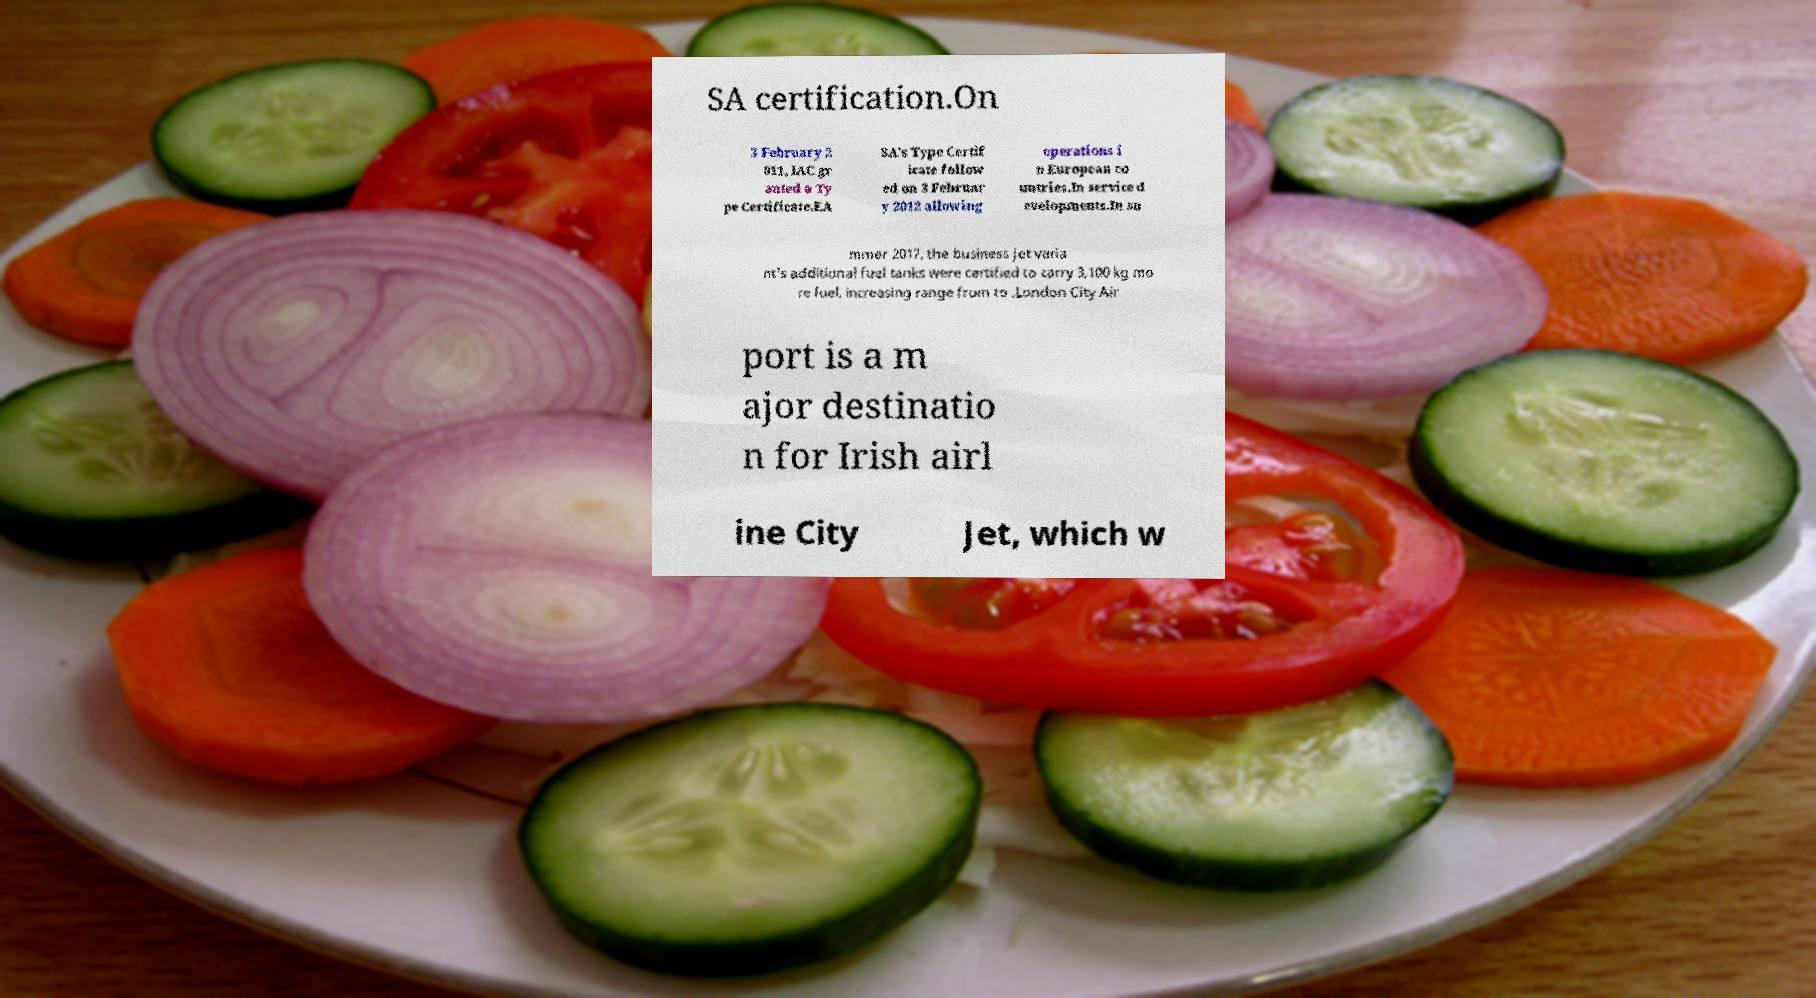Could you extract and type out the text from this image? SA certification.On 3 February 2 011, IAC gr anted a Ty pe Certificate.EA SA's Type Certif icate follow ed on 3 Februar y 2012 allowing operations i n European co untries.In service d evelopments.In su mmer 2017, the business jet varia nt's additional fuel tanks were certified to carry 3,100 kg mo re fuel, increasing range from to .London City Air port is a m ajor destinatio n for Irish airl ine City Jet, which w 